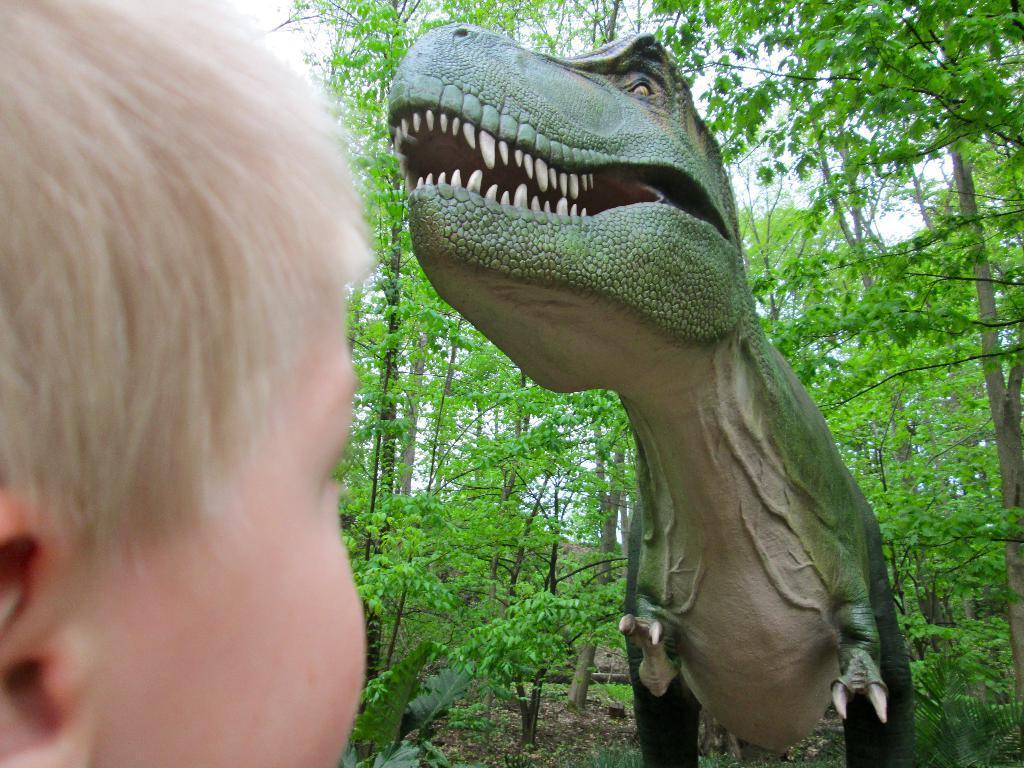Could you give a brief overview of what you see in this image? In this image we can see a sculpture and a kid, there are some trees and also we can see the sky. 